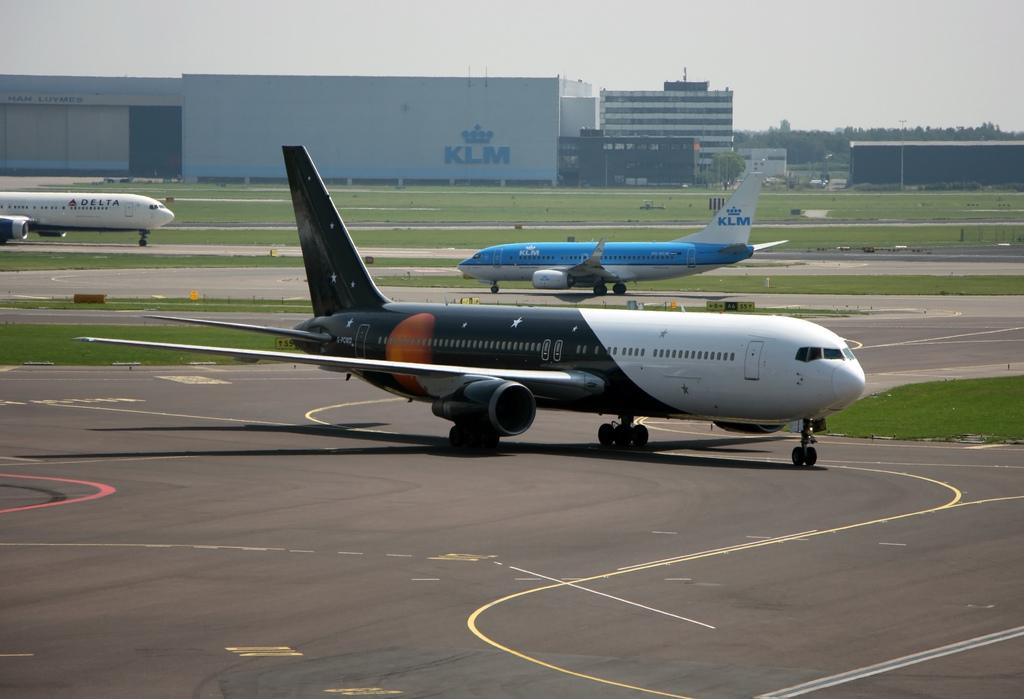What is the main subject of the image? The main subject of the image is an aircraft. Where is the aircraft located in the image? The aircraft is on the ground. What can be seen in the background of the image? There are buildings and the sky visible in the background of the image. What type of plantation can be seen near the aircraft in the image? There is no plantation present in the image; it features an aircraft on the ground with buildings and the sky visible in the background. 